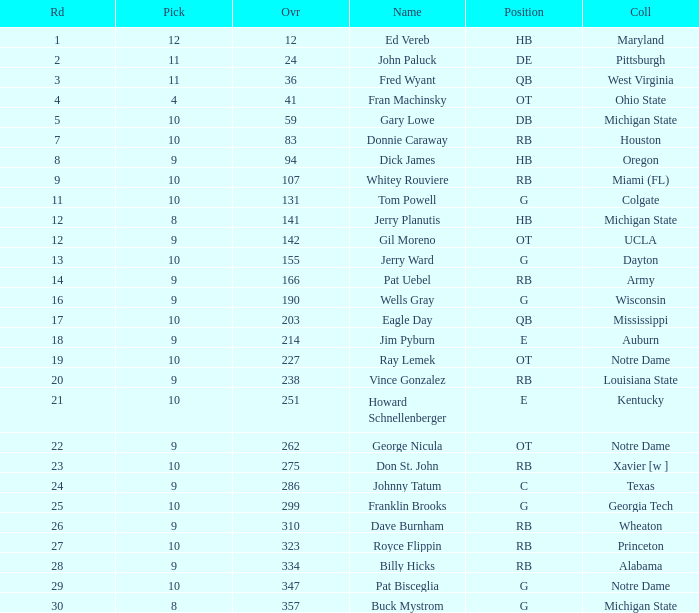What is the average number of rounds for billy hicks who had an overall pick number bigger than 310? 28.0. 